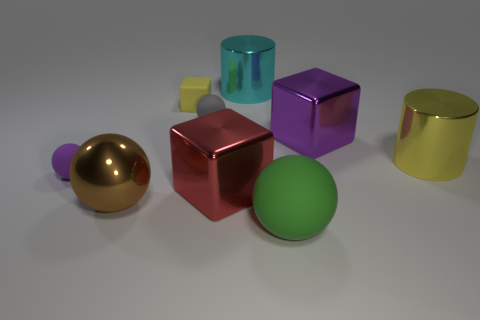Is there a metal cylinder that has the same color as the tiny matte cube?
Give a very brief answer. Yes. There is a sphere that is both in front of the purple matte object and left of the matte cube; what color is it?
Give a very brief answer. Brown. Is the big brown metallic thing the same shape as the gray thing?
Keep it short and to the point. Yes. There is a cylinder that is the same color as the matte cube; what is its size?
Your response must be concise. Large. What shape is the purple object in front of the big metal cylinder in front of the yellow cube?
Ensure brevity in your answer.  Sphere. There is a red object; is its shape the same as the matte thing that is on the right side of the small gray object?
Your answer should be very brief. No. There is a sphere that is the same size as the green matte object; what color is it?
Offer a terse response. Brown. Is the number of big yellow metallic cylinders to the left of the big cyan cylinder less than the number of large things right of the green thing?
Your response must be concise. Yes. There is a rubber thing that is on the right side of the metal object that is behind the rubber sphere behind the yellow metal cylinder; what is its shape?
Provide a short and direct response. Sphere. Do the large cylinder to the left of the purple metallic thing and the big block that is behind the yellow metallic cylinder have the same color?
Offer a very short reply. No. 